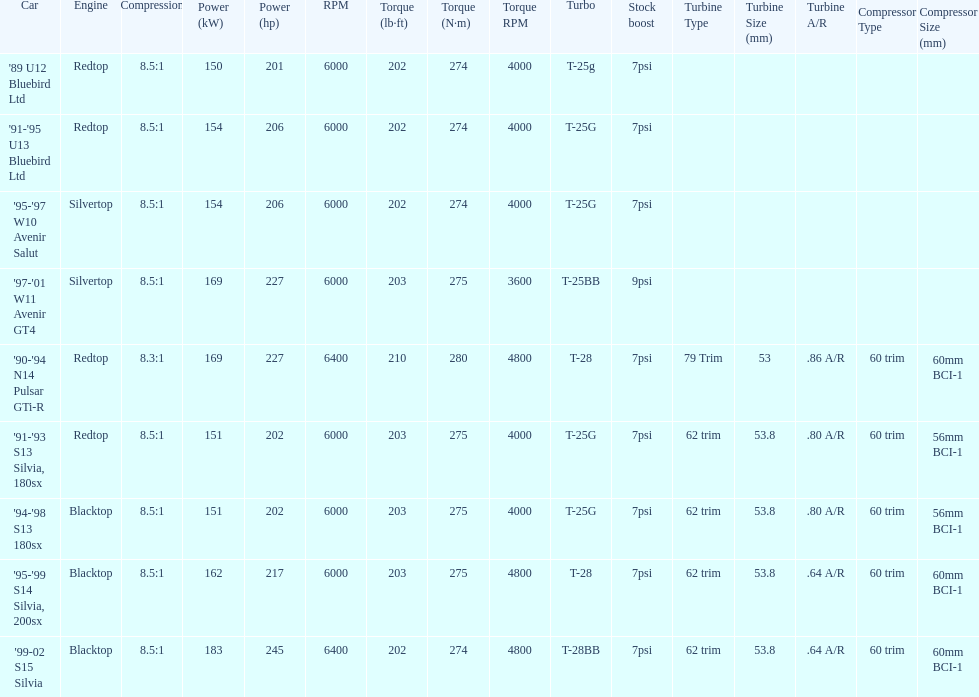Which engine has the smallest compression rate? '90-'94 N14 Pulsar GTi-R. 